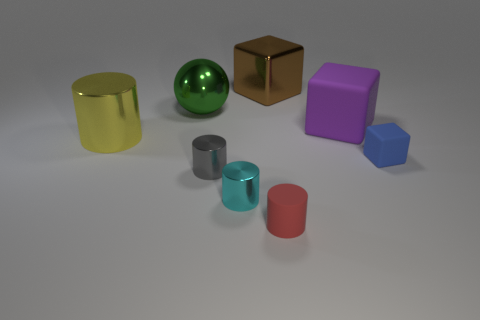Subtract all red matte cylinders. How many cylinders are left? 3 Add 1 small brown matte balls. How many objects exist? 9 Subtract 1 cylinders. How many cylinders are left? 3 Subtract all blue cubes. How many cubes are left? 2 Subtract all blocks. How many objects are left? 5 Add 6 large brown shiny cubes. How many large brown shiny cubes exist? 7 Subtract 1 blue blocks. How many objects are left? 7 Subtract all yellow cubes. Subtract all red spheres. How many cubes are left? 3 Subtract all small purple objects. Subtract all cyan metal things. How many objects are left? 7 Add 7 big purple rubber objects. How many big purple rubber objects are left? 8 